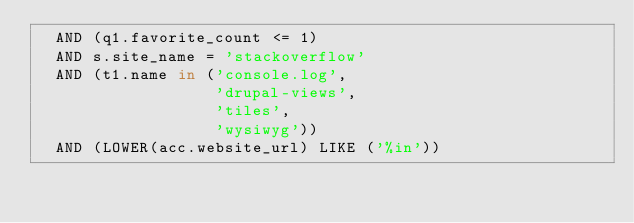<code> <loc_0><loc_0><loc_500><loc_500><_SQL_>  AND (q1.favorite_count <= 1)
  AND s.site_name = 'stackoverflow'
  AND (t1.name in ('console.log',
                   'drupal-views',
                   'tiles',
                   'wysiwyg'))
  AND (LOWER(acc.website_url) LIKE ('%in'))</code> 